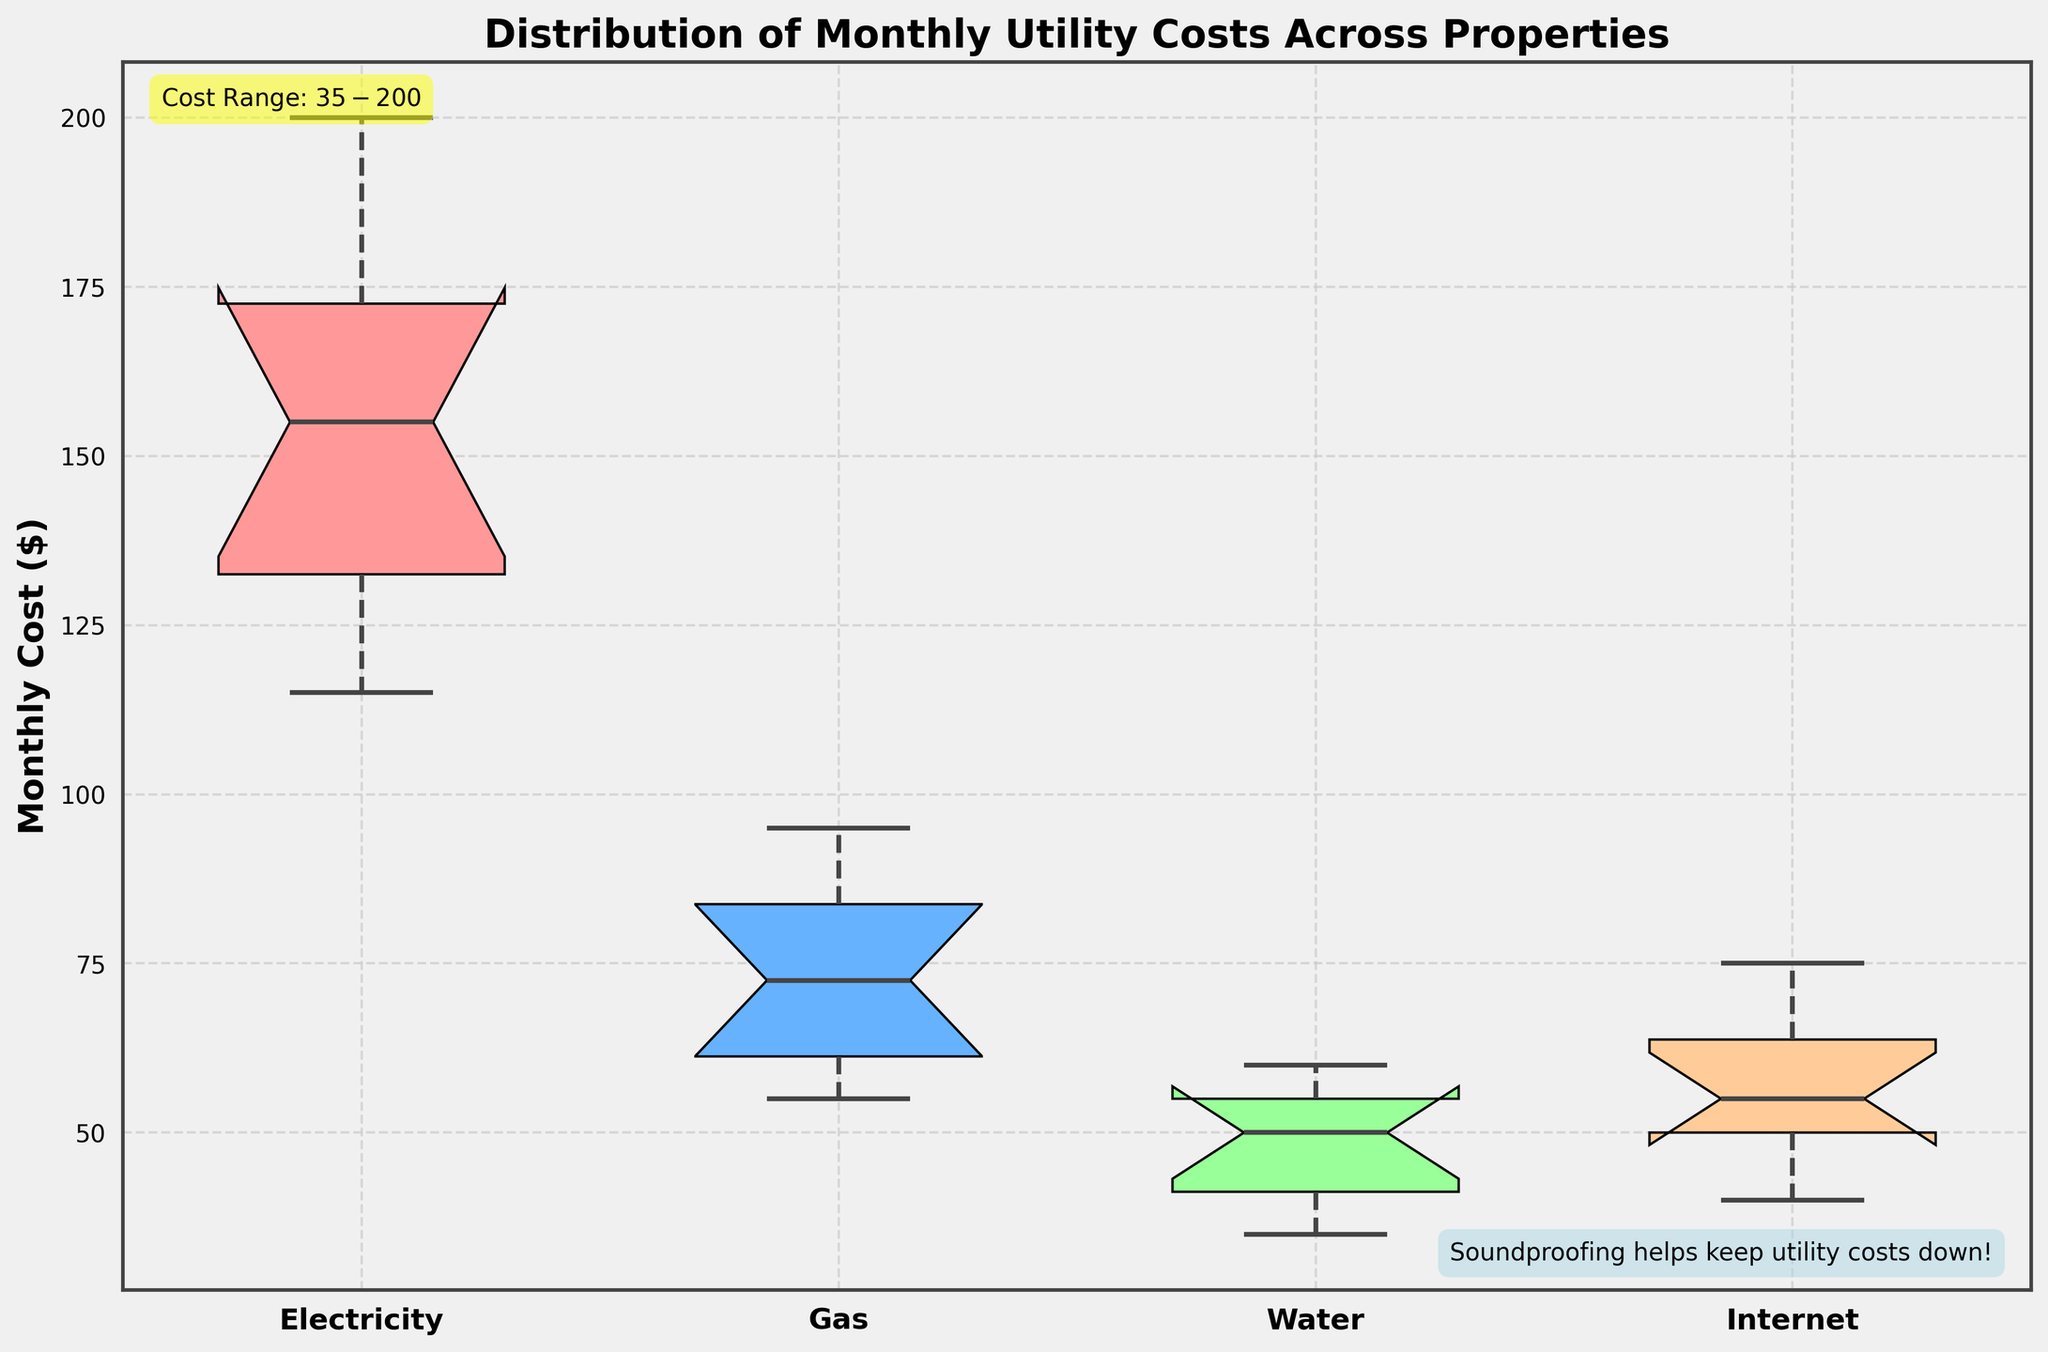what is the title of the plot? The title of the plot is clearly mentioned at the top of the figure. It reads "Distribution of Monthly Utility Costs Across Properties".
Answer: Distribution of Monthly Utility Costs Across Properties What utility has the highest median cost? By looking at the middle line (median) in the boxes, we can see that the one for Electricity is positioned highest compared to Gas, Water, and Internet.
Answer: Electricity What is the cost range mentioned in the plot? The cost range is annotated in the top left corner of the plot.
Answer: $35 - $200 Which utility has the largest interquartile range (IQR)? The interquartile range is the width of the box in the box plot. The box for Gas seems the widest among Electricity, Gas, Water, and Internet.
Answer: Gas Which utility has the smallest range between its whiskers? The range between the whiskers represents the overall spread of the data. Water's whiskers are closest together.
Answer: Water What is the median cost of Gas? By analyzing the middle line in the Gas box, we can approximate its position relative to the y-axis. The median cost appears to be around 75 dollars.
Answer: 75 dollars Which utility has the lowest median cost? By observing the median lines across all utility boxes, it’s clear that Internet has the lowest median cost compared to the others.
Answer: Internet How does the range of Internet costs compare to the range of Electricity costs? The whiskers for Internet and Electricity both show the spread of the data. Internet’s range appears smaller as the whiskers are closer together compared to Electricity.
Answer: Internet has a smaller range than Electricity What insights does the annotation at the bottom right of the plot provide? The annotation found at the bottom right reads "Soundproofing helps keep utility costs down!" and suggests that soundproofing might lead to lower utility costs, linking it to the persona's context.
Answer: Soundproofing helps keep utility costs down Which utility shows noticeable outliers and what are they? Outliers are represented by individual points outside the whiskers. Gas shows noticeable outliers, seen as points above and below the whiskers.
Answer: Gas 